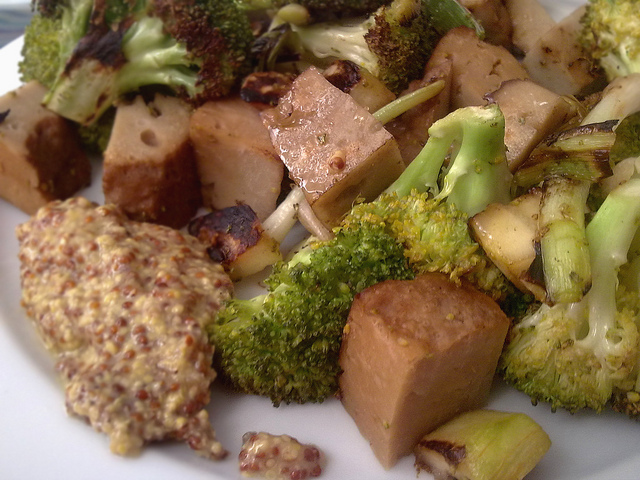Can you describe what's on the dish in the image? The dish in the image contains grilled tofu, broccoli, and other vegetables, possibly including mushrooms and some green onions. The tofu looks marinated and is accompanied by a side of mustard, perhaps for dipping. 